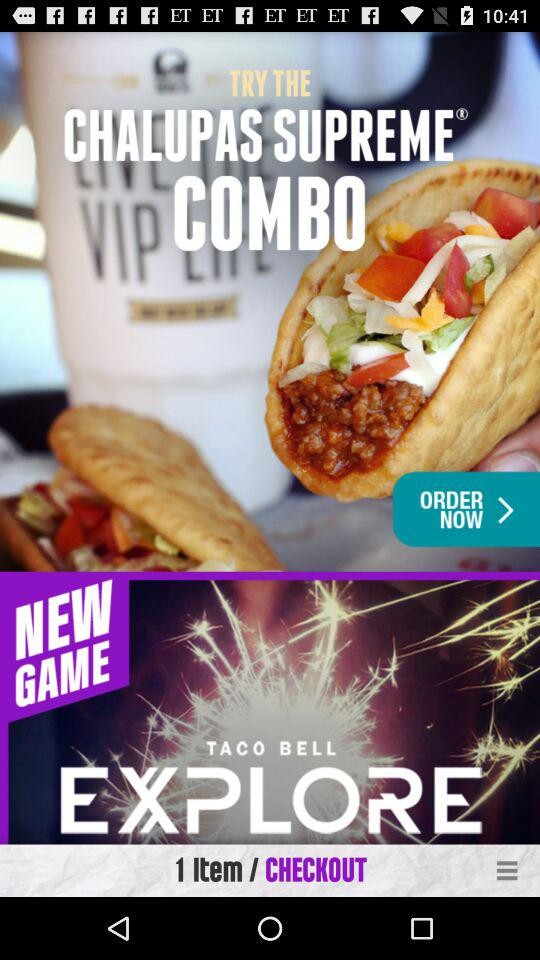How many items are in the cart?
Answer the question using a single word or phrase. 1 